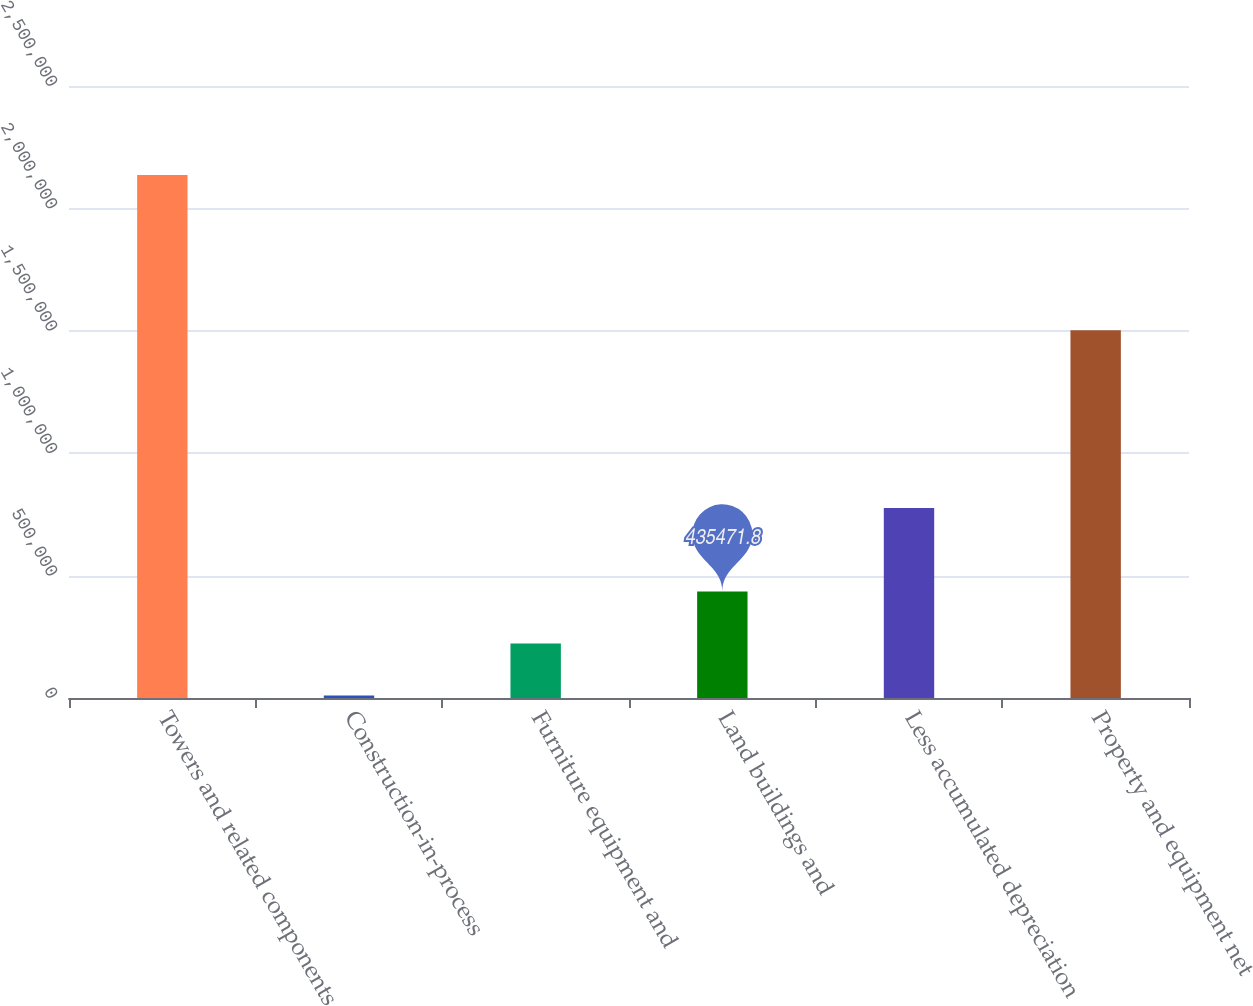Convert chart. <chart><loc_0><loc_0><loc_500><loc_500><bar_chart><fcel>Towers and related components<fcel>Construction-in-process<fcel>Furniture equipment and<fcel>Land buildings and<fcel>Less accumulated depreciation<fcel>Property and equipment net<nl><fcel>2.13618e+06<fcel>10295<fcel>222883<fcel>435472<fcel>776263<fcel>1.50267e+06<nl></chart> 